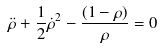Convert formula to latex. <formula><loc_0><loc_0><loc_500><loc_500>\ddot { \rho } + \frac { 1 } { 2 } { \dot { \rho } } ^ { 2 } - \frac { ( 1 - { \rho } ) } { \rho } = 0</formula> 